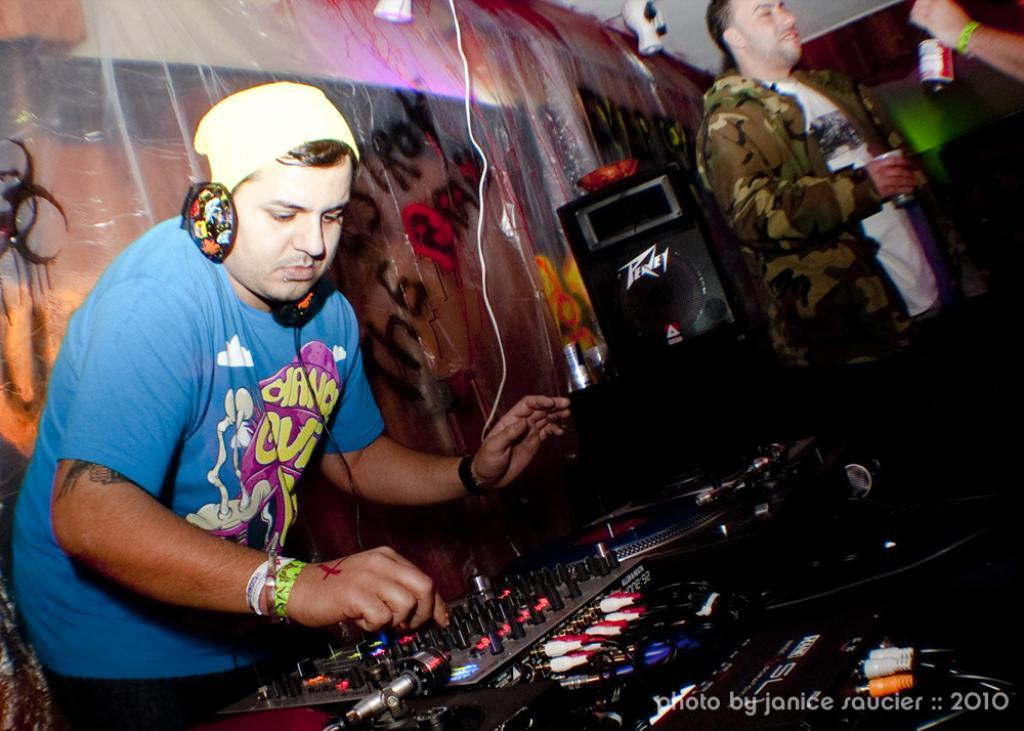What objects are located at the bottom of the image? There are electronic devices at the bottom of the image. What are the people behind the electronic devices doing? The people are standing behind the electronic devices and holding bottles. What type of audio equipment is visible in the image? There are speakers visible in the image. What can be seen in the background of the image? There is a wall in the background of the image. What type of alarm can be heard ringing in the image? There is no alarm ringing in the image; it only shows people standing behind electronic devices and holding bottles. How many bells are visible on the fingers of the people in the image? There are no bells visible on the fingers of the people in the image. 